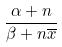Convert formula to latex. <formula><loc_0><loc_0><loc_500><loc_500>\frac { \alpha + n } { \beta + n \overline { x } }</formula> 